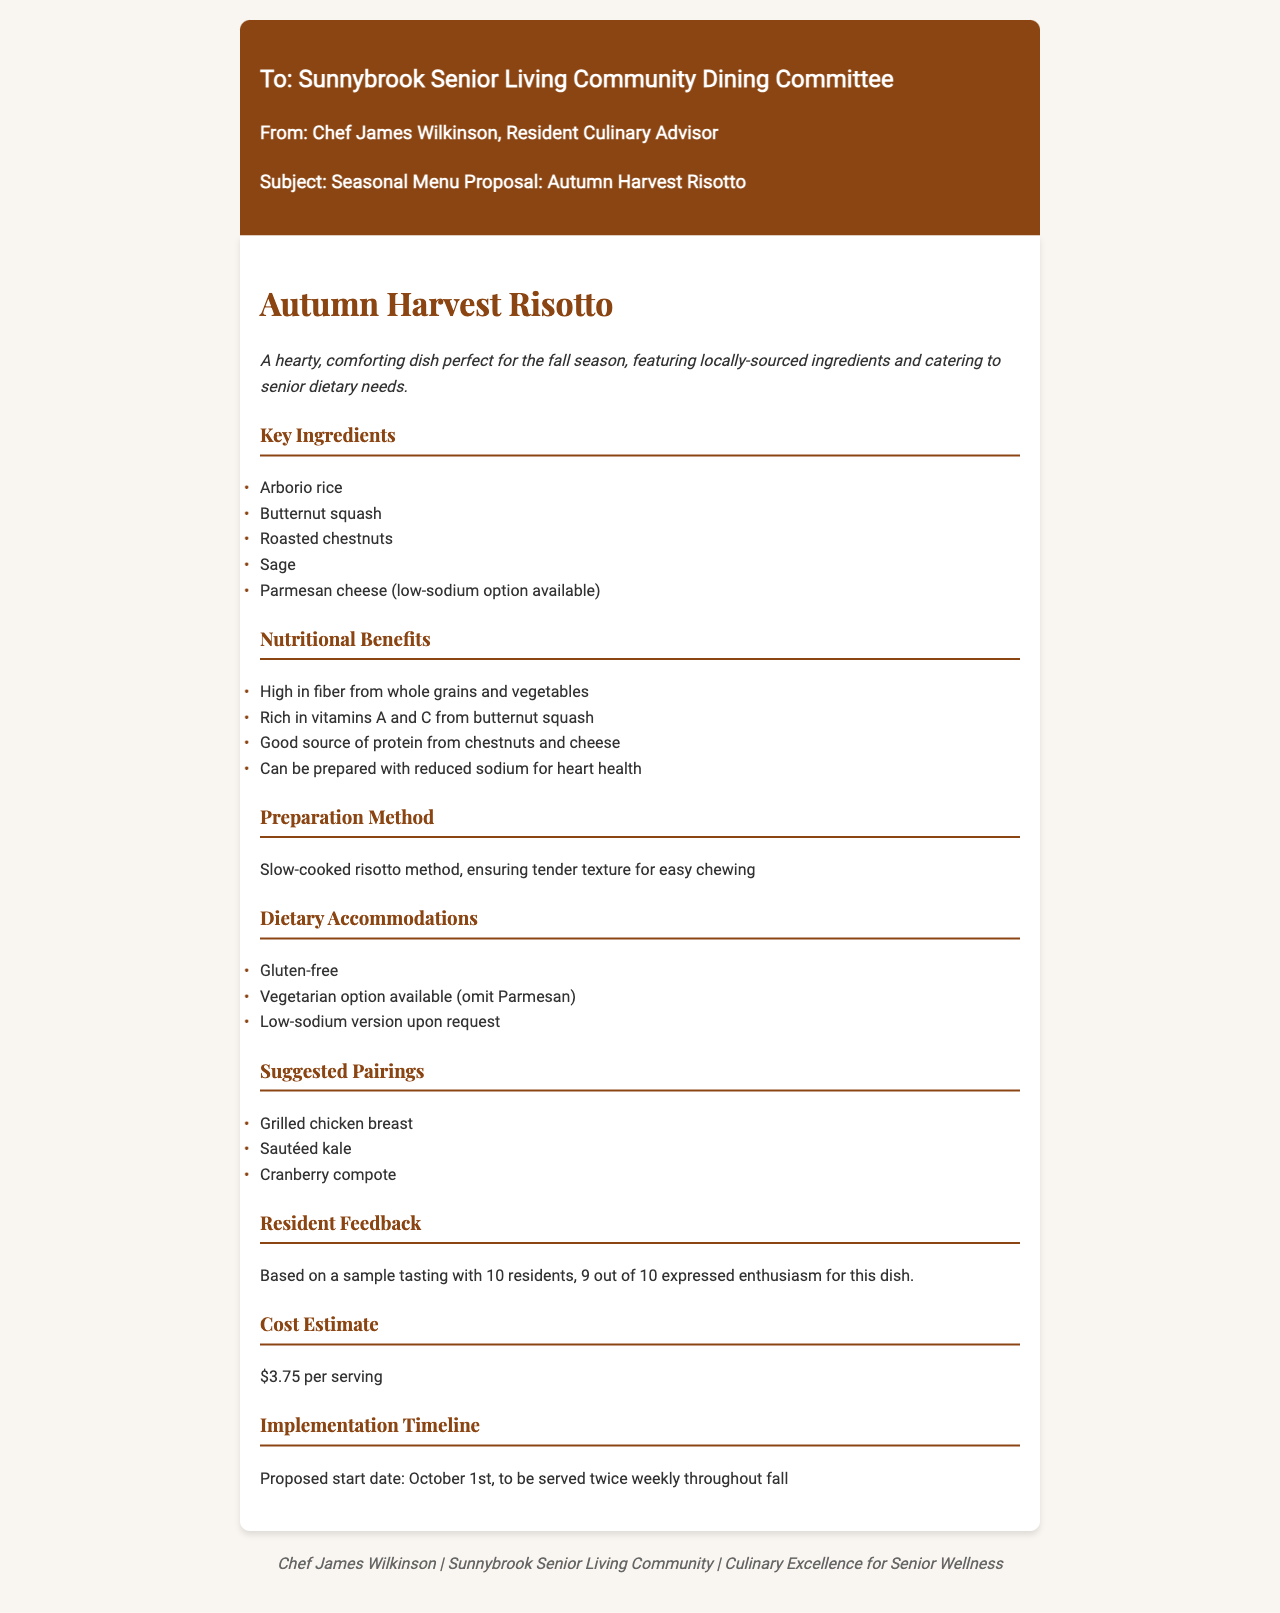what is the title of the proposed dish? The title of the proposed dish is presented in the heading of the document as "Autumn Harvest Risotto".
Answer: Autumn Harvest Risotto who is the sender of the fax? The sender of the fax is indicated at the beginning as Chef James Wilkinson, the Resident Culinary Advisor.
Answer: Chef James Wilkinson what are two suggested pairings for the dish? The suggested pairings are listed in the document, including grilled chicken breast and sautéed kale.
Answer: Grilled chicken breast, sautéed kale how many residents participated in the tasting? The document states that 10 residents were involved in the tasting of the dish.
Answer: 10 what is the cost estimate per serving? The cost estimate per serving is mentioned clearly in the document as $3.75.
Answer: $3.75 what is the proposed start date for serving the dish? The proposed start date is specified in the timeline section as October 1st.
Answer: October 1st how many residents expressed enthusiasm for the dish? The document mentions that 9 out of 10 residents expressed enthusiasm for the dish.
Answer: 9 what type of dietary option is provided for those requesting a low-sodium version? The document states that a low-sodium version can be requested as an accommodation for dietary needs.
Answer: Low-sodium version what is the main cooking method suggested for the dish? The preparation method is described in the document as a slow-cooked risotto method.
Answer: Slow-cooked risotto method 